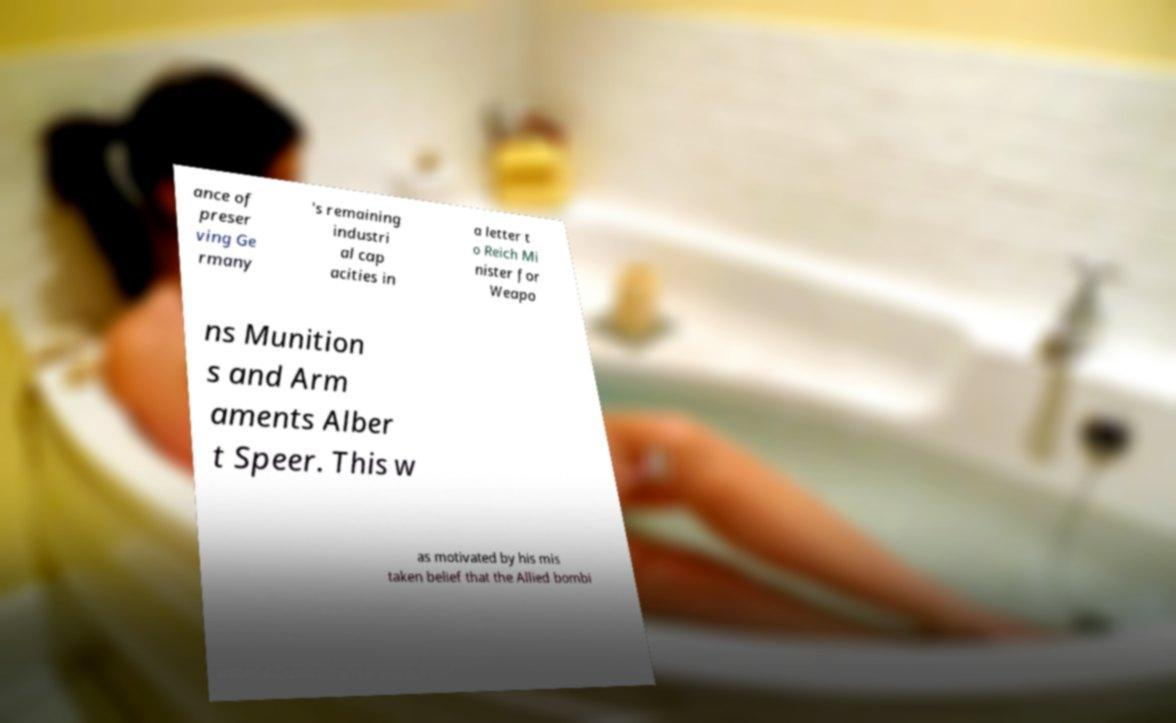I need the written content from this picture converted into text. Can you do that? ance of preser ving Ge rmany 's remaining industri al cap acities in a letter t o Reich Mi nister for Weapo ns Munition s and Arm aments Alber t Speer. This w as motivated by his mis taken belief that the Allied bombi 